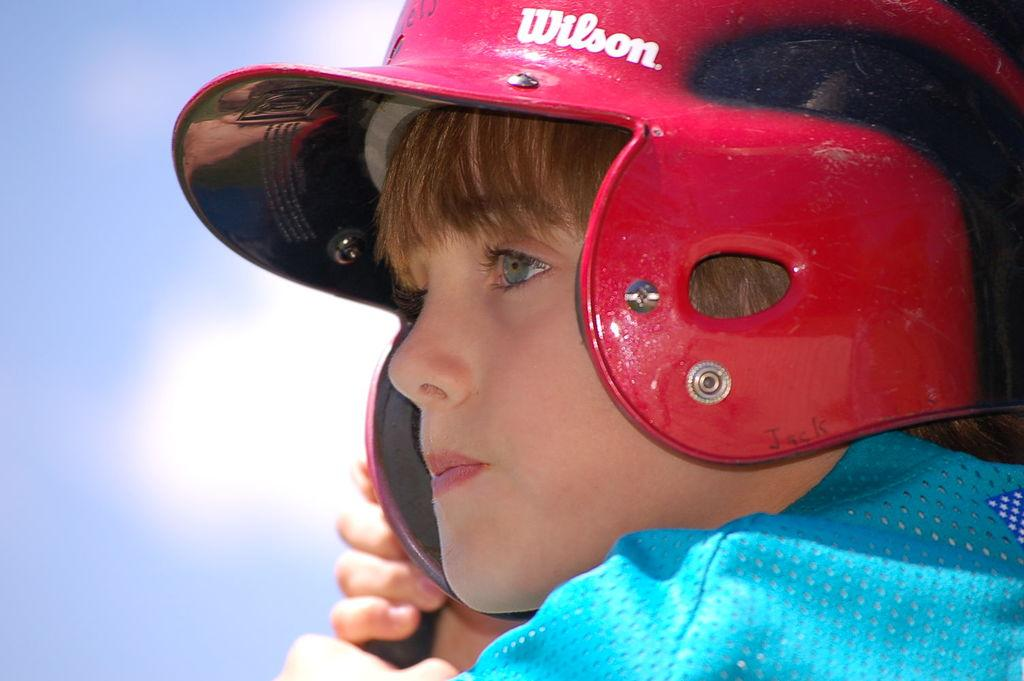Who is the main subject in the image? There is a boy in the image. What is the boy wearing on his upper body? The boy is wearing a blue shirt. What is the boy wearing on his head? The boy is wearing a red helmet. What is the boy holding in the image? The boy is holding an object. What can be seen in the background of the image? There is a sky visible in the background of the image. What type of tax is being discussed in the image? There is no discussion of tax in the image; it features a boy wearing a blue shirt, a red helmet, and holding an object. How does the smoke affect the boy's journey in the image? There is no smoke or journey present in the image; it only shows a boy with a helmet and an object. 